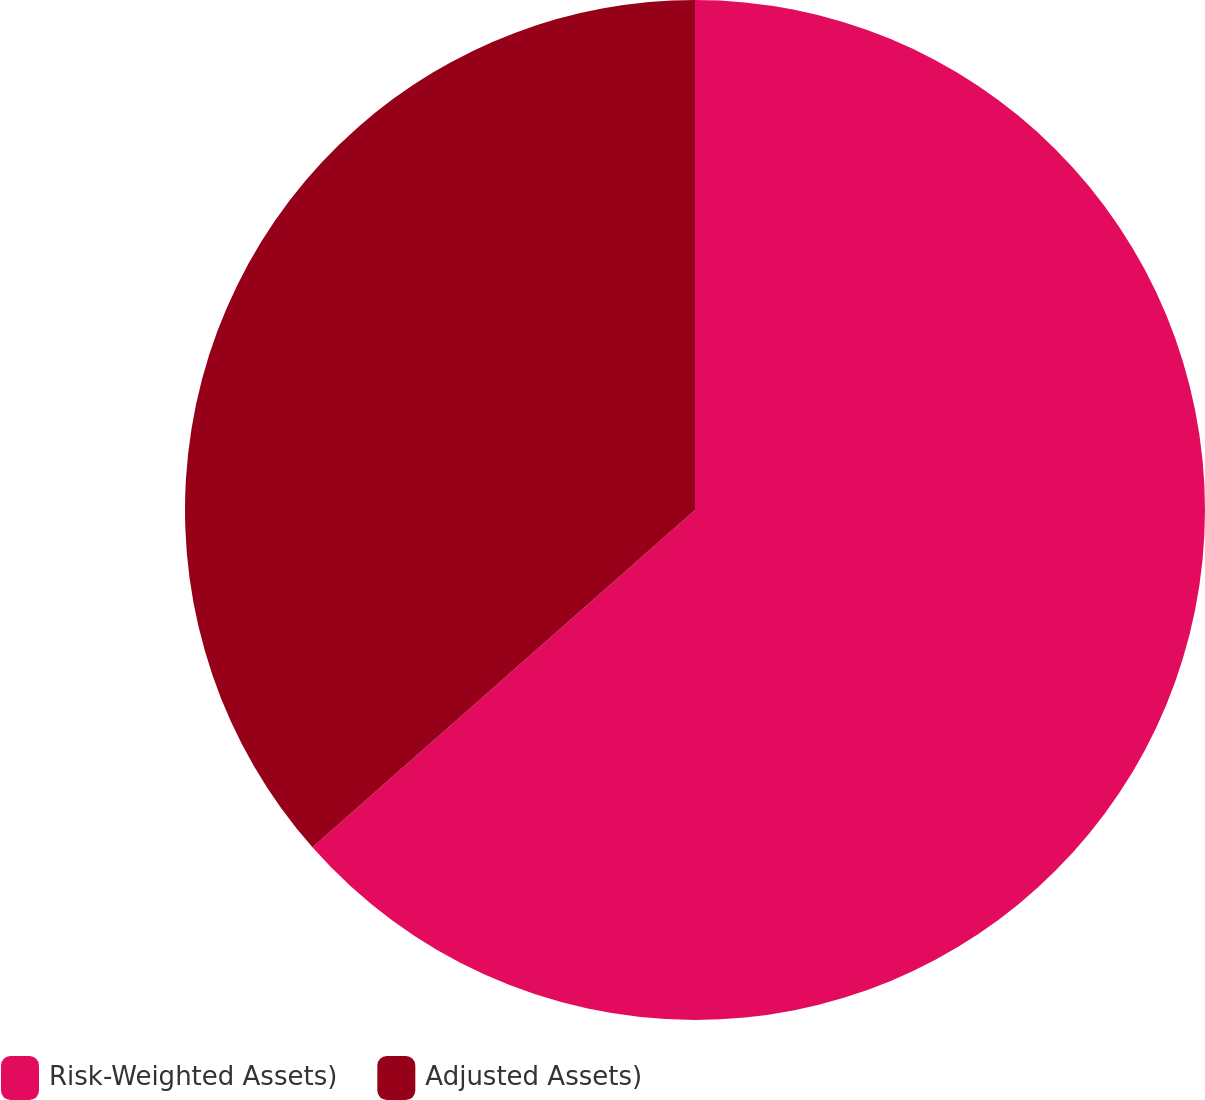<chart> <loc_0><loc_0><loc_500><loc_500><pie_chart><fcel>Risk-Weighted Assets)<fcel>Adjusted Assets)<nl><fcel>63.5%<fcel>36.5%<nl></chart> 